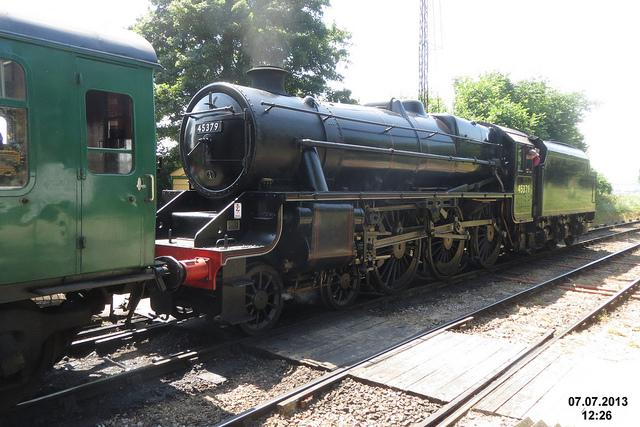Who invented this vehicle?

Choices:
A) richard trevithick
B) orville wright
C) jeff goldblum
D) bill nye richard trevithick 